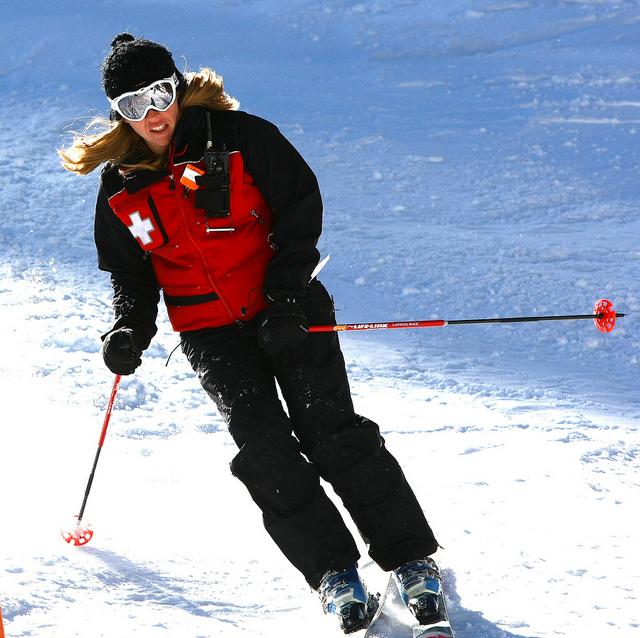Is the woman skiing?
Short answer required. Yes. Is the skier in powder?
Short answer required. No. What is the woman holding?
Write a very short answer. Ski poles. 